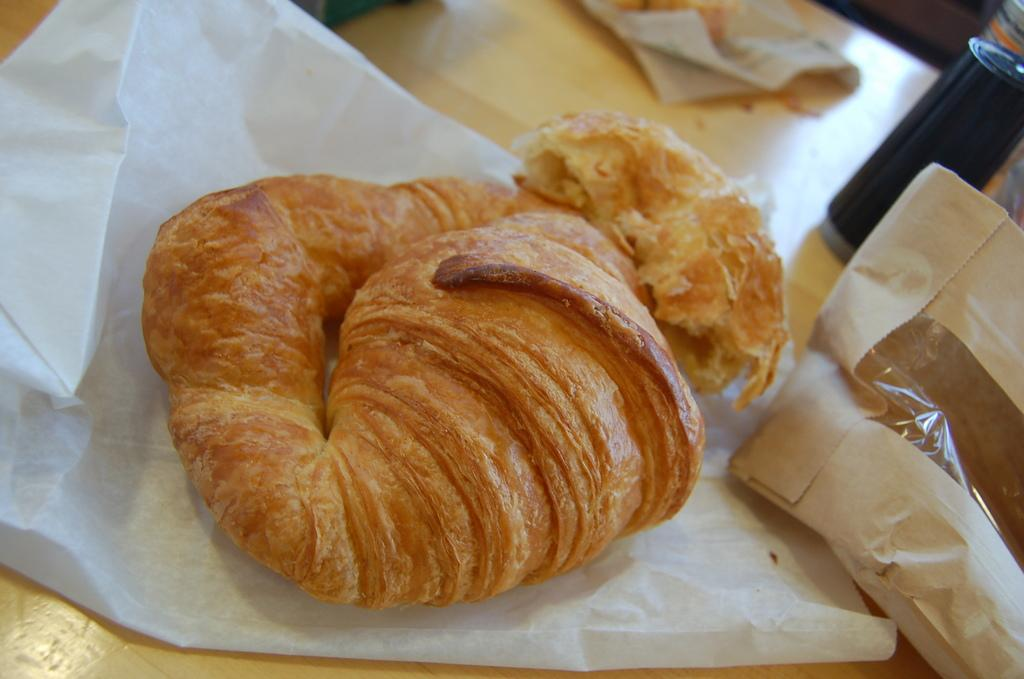What type of containers are used for the food items in the image? The food items are on papers and packets in the image. How many different types of containers are visible? There are two types of containers visible: papers and packets. Can you describe the objects on the table in the image? There are two objects on the table in the image, which are the food items on papers and packets. What type of toys can be seen on the table in the image? There are no toys present in the image; it only features food items on papers and packets. 